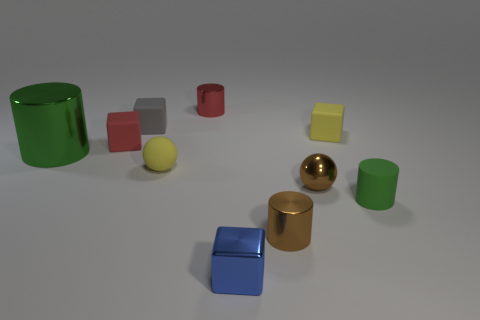Is the number of yellow things that are on the left side of the tiny green thing the same as the number of green objects?
Provide a succinct answer. Yes. What material is the yellow object in front of the small yellow rubber thing behind the small red rubber block?
Offer a very short reply. Rubber. What is the shape of the blue shiny object?
Give a very brief answer. Cube. Are there an equal number of small red shiny cylinders that are in front of the tiny red block and matte things in front of the blue shiny block?
Your answer should be very brief. Yes. Is the color of the tiny rubber ball that is behind the tiny green rubber cylinder the same as the small shiny cylinder that is in front of the tiny rubber sphere?
Keep it short and to the point. No. Are there more big things that are behind the large green shiny thing than small green rubber cylinders?
Your response must be concise. No. What shape is the gray object that is made of the same material as the small yellow ball?
Give a very brief answer. Cube. There is a gray matte thing on the left side of the blue metal object; does it have the same size as the metal ball?
Offer a very short reply. Yes. There is a green thing behind the green cylinder in front of the big object; what is its shape?
Your answer should be very brief. Cylinder. There is a green cylinder left of the small red object that is on the left side of the red cylinder; how big is it?
Offer a very short reply. Large. 